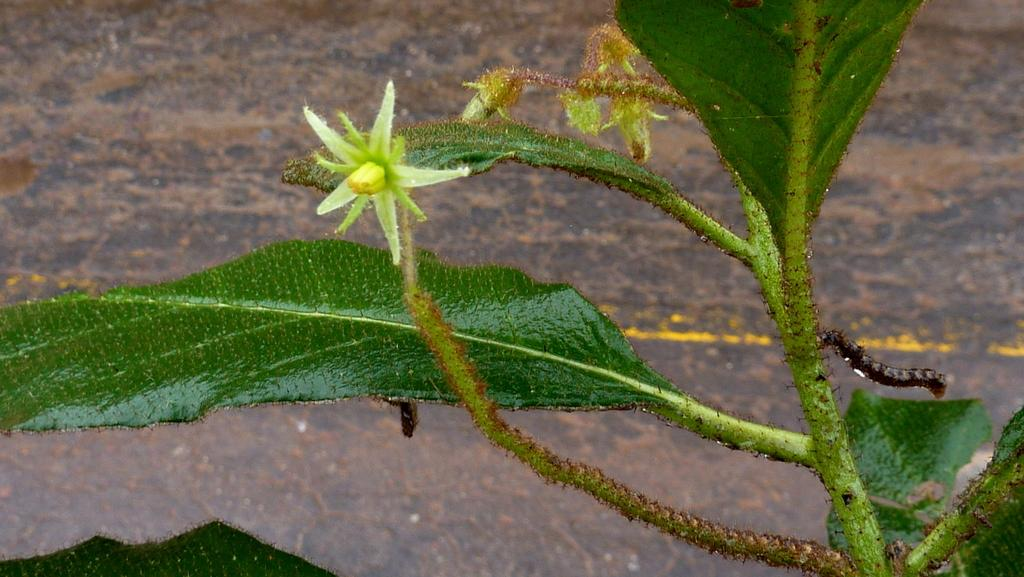What type of plant is visible in the image? There is a plant with a flower in the image. Are there any living organisms interacting with the plant? Yes, there are two insects on the plant. What type of health advice does the doctor give to the plant in the image? There is no doctor present in the image, and therefore no health advice can be given to the plant. 